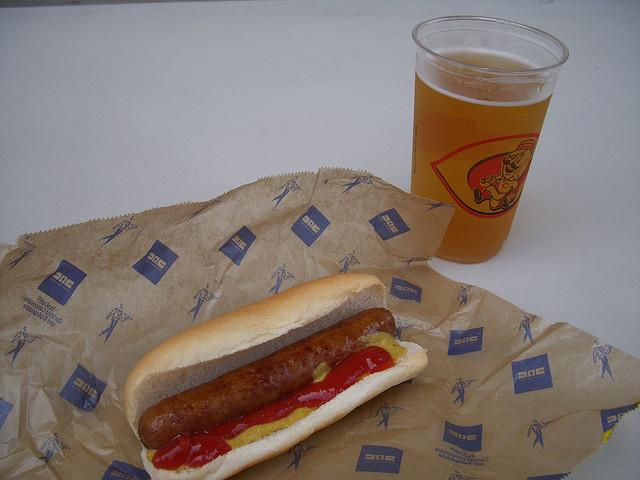Is relish on the hot dog?
Keep it brief. No. What liquid is in the cup?
Be succinct. Beer. What sports team is on the cup?
Short answer required. Cincinnati reds. Is there ketchup on the hot dog?
Keep it brief. Yes. 